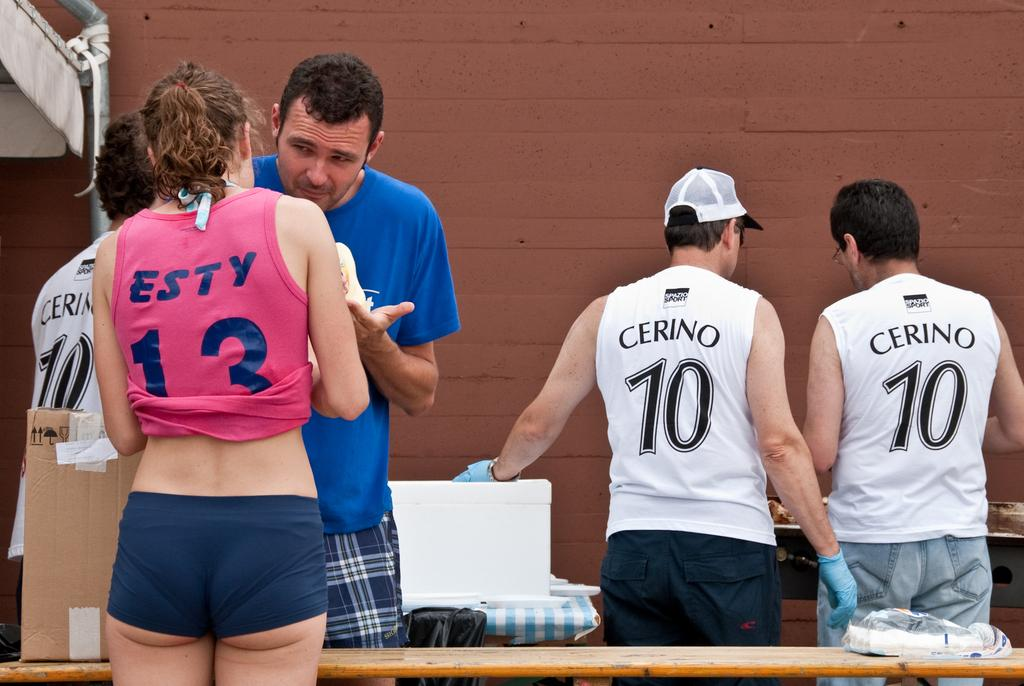<image>
Relay a brief, clear account of the picture shown. A girl wearing a pink ESTY shirt stands near two men wearing CERINO shirts 